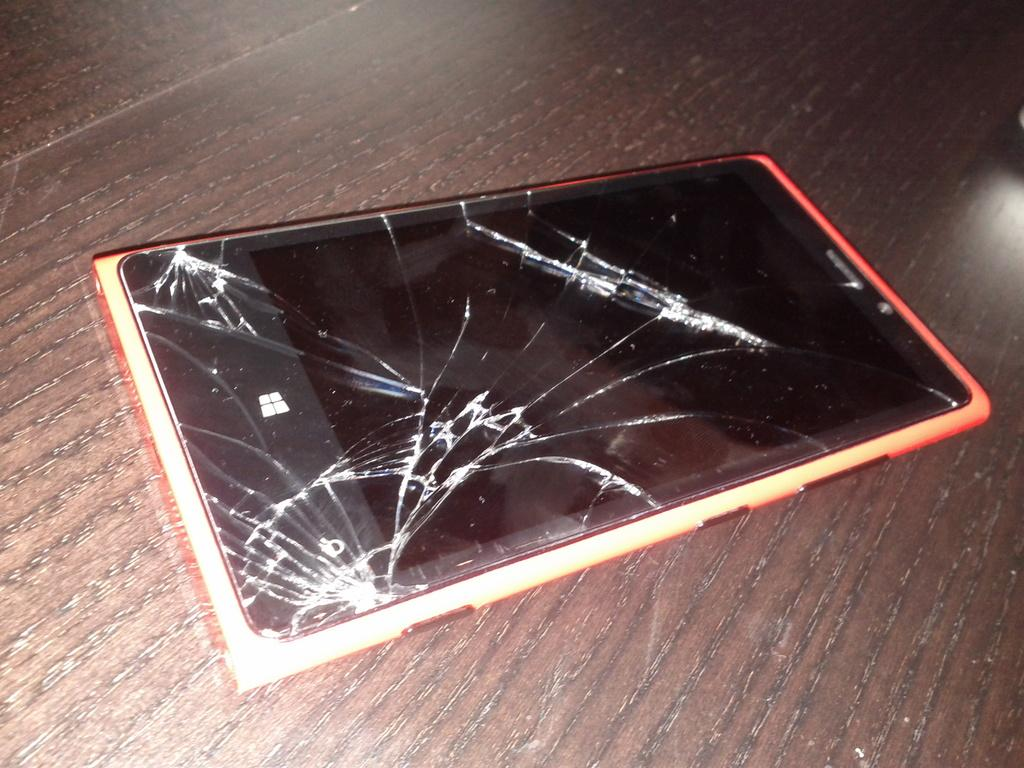What object is the main focus of the image? There is a mobile in the image. Can you describe the condition of the mobile? The mobile has cracks on it. Where is the mobile located in the image? The mobile is placed on a platform. What time of day is the reward being delivered in the image? There is no mention of a reward or a specific time of day in the image. The image only shows a mobile with cracks on it, placed on a platform. 